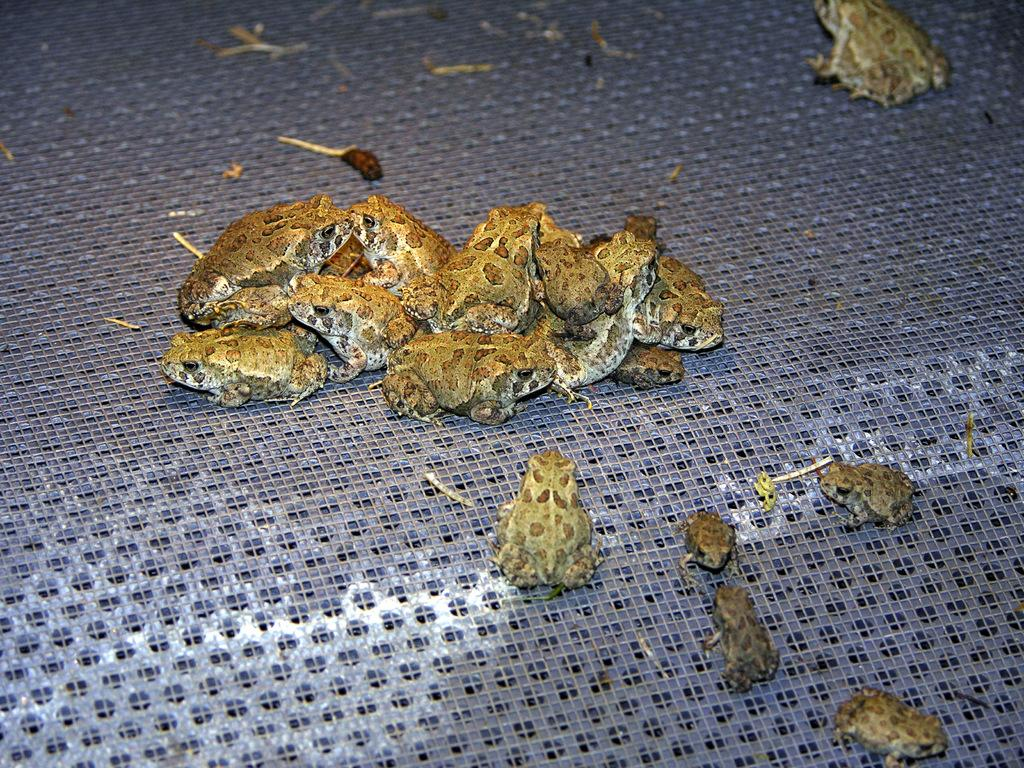What type of animals are in the image? There are frogs in the image. Where are the frogs located? The frogs are on the floor. What color are the frogs? The frogs are brown in color. What color is the floor? The floor is purple in color. What type of bead is being used to decorate the flower in the image? There is no bead or flower present in the image; it features frogs on a purple floor. 